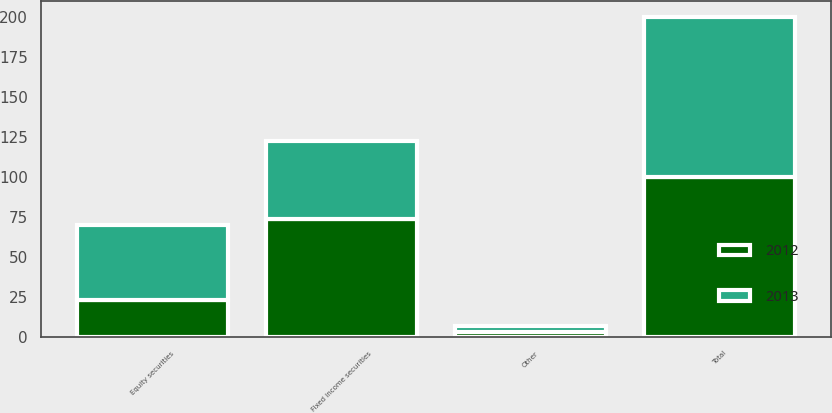<chart> <loc_0><loc_0><loc_500><loc_500><stacked_bar_chart><ecel><fcel>Equity securities<fcel>Fixed income securities<fcel>Other<fcel>Total<nl><fcel>2012<fcel>23<fcel>74<fcel>3<fcel>100<nl><fcel>2013<fcel>47<fcel>49<fcel>4<fcel>100<nl></chart> 